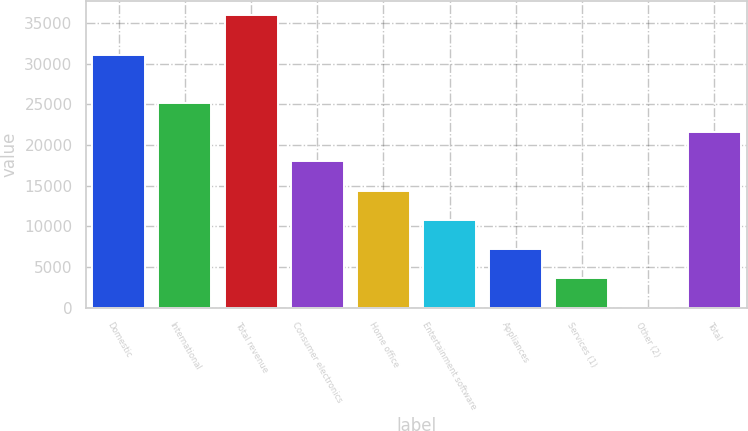Convert chart to OTSL. <chart><loc_0><loc_0><loc_500><loc_500><bar_chart><fcel>Domestic<fcel>International<fcel>Total revenue<fcel>Consumer electronics<fcel>Home office<fcel>Entertainment software<fcel>Appliances<fcel>Services (1)<fcel>Other (2)<fcel>Total<nl><fcel>31031<fcel>25154.1<fcel>35934<fcel>17967.5<fcel>14374.2<fcel>10780.9<fcel>7187.6<fcel>3594.3<fcel>1<fcel>21560.8<nl></chart> 